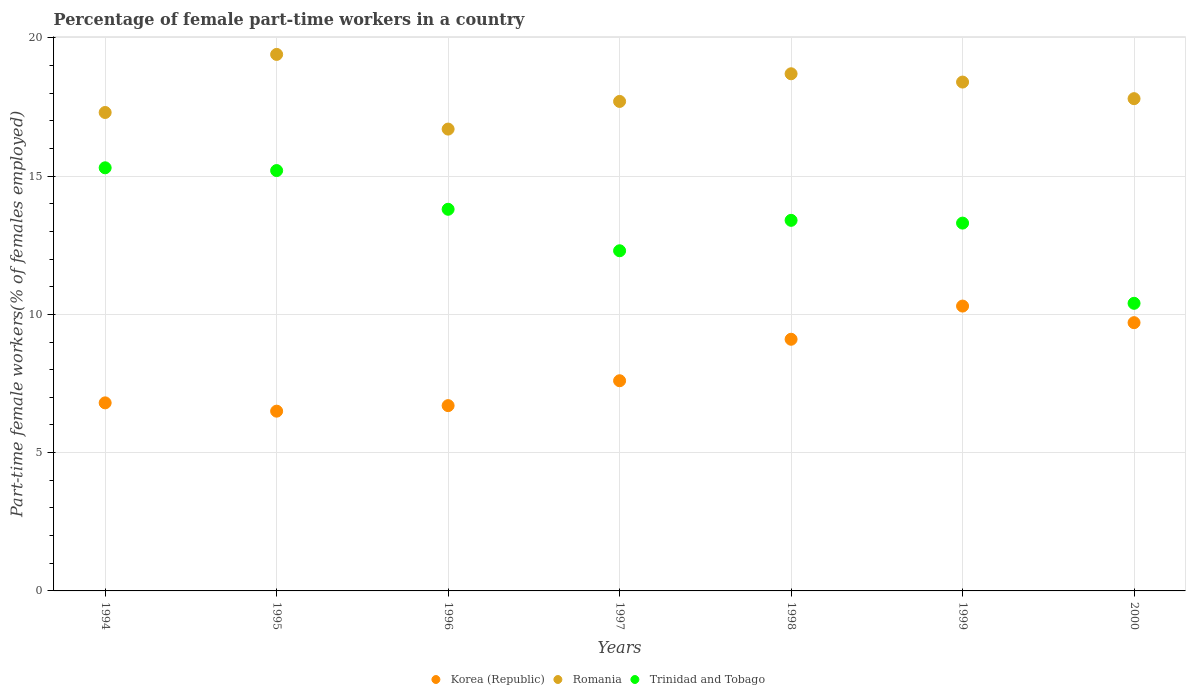How many different coloured dotlines are there?
Keep it short and to the point. 3. What is the percentage of female part-time workers in Trinidad and Tobago in 1997?
Make the answer very short. 12.3. Across all years, what is the maximum percentage of female part-time workers in Korea (Republic)?
Offer a terse response. 10.3. Across all years, what is the minimum percentage of female part-time workers in Trinidad and Tobago?
Give a very brief answer. 10.4. What is the total percentage of female part-time workers in Romania in the graph?
Make the answer very short. 126. What is the difference between the percentage of female part-time workers in Romania in 1994 and that in 1996?
Ensure brevity in your answer.  0.6. What is the difference between the percentage of female part-time workers in Korea (Republic) in 1997 and the percentage of female part-time workers in Romania in 2000?
Offer a terse response. -10.2. What is the average percentage of female part-time workers in Trinidad and Tobago per year?
Make the answer very short. 13.39. In the year 1995, what is the difference between the percentage of female part-time workers in Romania and percentage of female part-time workers in Trinidad and Tobago?
Offer a very short reply. 4.2. In how many years, is the percentage of female part-time workers in Romania greater than 16 %?
Ensure brevity in your answer.  7. What is the ratio of the percentage of female part-time workers in Trinidad and Tobago in 1994 to that in 1997?
Give a very brief answer. 1.24. What is the difference between the highest and the second highest percentage of female part-time workers in Korea (Republic)?
Your answer should be very brief. 0.6. What is the difference between the highest and the lowest percentage of female part-time workers in Korea (Republic)?
Offer a very short reply. 3.8. In how many years, is the percentage of female part-time workers in Trinidad and Tobago greater than the average percentage of female part-time workers in Trinidad and Tobago taken over all years?
Give a very brief answer. 4. Is the percentage of female part-time workers in Trinidad and Tobago strictly greater than the percentage of female part-time workers in Korea (Republic) over the years?
Give a very brief answer. Yes. How many dotlines are there?
Your response must be concise. 3. How many years are there in the graph?
Your response must be concise. 7. Does the graph contain any zero values?
Provide a short and direct response. No. Where does the legend appear in the graph?
Your response must be concise. Bottom center. What is the title of the graph?
Your answer should be compact. Percentage of female part-time workers in a country. Does "Qatar" appear as one of the legend labels in the graph?
Ensure brevity in your answer.  No. What is the label or title of the X-axis?
Give a very brief answer. Years. What is the label or title of the Y-axis?
Your answer should be very brief. Part-time female workers(% of females employed). What is the Part-time female workers(% of females employed) in Korea (Republic) in 1994?
Ensure brevity in your answer.  6.8. What is the Part-time female workers(% of females employed) in Romania in 1994?
Provide a succinct answer. 17.3. What is the Part-time female workers(% of females employed) of Trinidad and Tobago in 1994?
Offer a very short reply. 15.3. What is the Part-time female workers(% of females employed) of Romania in 1995?
Provide a succinct answer. 19.4. What is the Part-time female workers(% of females employed) of Trinidad and Tobago in 1995?
Offer a very short reply. 15.2. What is the Part-time female workers(% of females employed) of Korea (Republic) in 1996?
Offer a terse response. 6.7. What is the Part-time female workers(% of females employed) of Romania in 1996?
Offer a very short reply. 16.7. What is the Part-time female workers(% of females employed) of Trinidad and Tobago in 1996?
Give a very brief answer. 13.8. What is the Part-time female workers(% of females employed) of Korea (Republic) in 1997?
Your response must be concise. 7.6. What is the Part-time female workers(% of females employed) of Romania in 1997?
Your answer should be compact. 17.7. What is the Part-time female workers(% of females employed) in Trinidad and Tobago in 1997?
Your response must be concise. 12.3. What is the Part-time female workers(% of females employed) of Korea (Republic) in 1998?
Make the answer very short. 9.1. What is the Part-time female workers(% of females employed) of Romania in 1998?
Offer a very short reply. 18.7. What is the Part-time female workers(% of females employed) of Trinidad and Tobago in 1998?
Keep it short and to the point. 13.4. What is the Part-time female workers(% of females employed) in Korea (Republic) in 1999?
Ensure brevity in your answer.  10.3. What is the Part-time female workers(% of females employed) in Romania in 1999?
Provide a succinct answer. 18.4. What is the Part-time female workers(% of females employed) in Trinidad and Tobago in 1999?
Keep it short and to the point. 13.3. What is the Part-time female workers(% of females employed) in Korea (Republic) in 2000?
Give a very brief answer. 9.7. What is the Part-time female workers(% of females employed) of Romania in 2000?
Ensure brevity in your answer.  17.8. What is the Part-time female workers(% of females employed) in Trinidad and Tobago in 2000?
Give a very brief answer. 10.4. Across all years, what is the maximum Part-time female workers(% of females employed) in Korea (Republic)?
Offer a terse response. 10.3. Across all years, what is the maximum Part-time female workers(% of females employed) of Romania?
Give a very brief answer. 19.4. Across all years, what is the maximum Part-time female workers(% of females employed) in Trinidad and Tobago?
Your response must be concise. 15.3. Across all years, what is the minimum Part-time female workers(% of females employed) of Romania?
Provide a succinct answer. 16.7. Across all years, what is the minimum Part-time female workers(% of females employed) in Trinidad and Tobago?
Provide a succinct answer. 10.4. What is the total Part-time female workers(% of females employed) in Korea (Republic) in the graph?
Provide a succinct answer. 56.7. What is the total Part-time female workers(% of females employed) of Romania in the graph?
Keep it short and to the point. 126. What is the total Part-time female workers(% of females employed) in Trinidad and Tobago in the graph?
Provide a succinct answer. 93.7. What is the difference between the Part-time female workers(% of females employed) of Romania in 1994 and that in 1995?
Provide a short and direct response. -2.1. What is the difference between the Part-time female workers(% of females employed) in Korea (Republic) in 1994 and that in 1996?
Give a very brief answer. 0.1. What is the difference between the Part-time female workers(% of females employed) of Trinidad and Tobago in 1994 and that in 1996?
Make the answer very short. 1.5. What is the difference between the Part-time female workers(% of females employed) of Korea (Republic) in 1994 and that in 1997?
Offer a terse response. -0.8. What is the difference between the Part-time female workers(% of females employed) in Korea (Republic) in 1994 and that in 1998?
Give a very brief answer. -2.3. What is the difference between the Part-time female workers(% of females employed) in Romania in 1994 and that in 1999?
Your response must be concise. -1.1. What is the difference between the Part-time female workers(% of females employed) of Trinidad and Tobago in 1994 and that in 1999?
Offer a terse response. 2. What is the difference between the Part-time female workers(% of females employed) of Korea (Republic) in 1994 and that in 2000?
Ensure brevity in your answer.  -2.9. What is the difference between the Part-time female workers(% of females employed) in Trinidad and Tobago in 1994 and that in 2000?
Ensure brevity in your answer.  4.9. What is the difference between the Part-time female workers(% of females employed) in Korea (Republic) in 1995 and that in 1996?
Offer a very short reply. -0.2. What is the difference between the Part-time female workers(% of females employed) in Romania in 1995 and that in 1997?
Give a very brief answer. 1.7. What is the difference between the Part-time female workers(% of females employed) of Trinidad and Tobago in 1995 and that in 1997?
Give a very brief answer. 2.9. What is the difference between the Part-time female workers(% of females employed) in Korea (Republic) in 1995 and that in 1998?
Offer a terse response. -2.6. What is the difference between the Part-time female workers(% of females employed) of Trinidad and Tobago in 1995 and that in 1999?
Give a very brief answer. 1.9. What is the difference between the Part-time female workers(% of females employed) in Korea (Republic) in 1995 and that in 2000?
Make the answer very short. -3.2. What is the difference between the Part-time female workers(% of females employed) in Trinidad and Tobago in 1995 and that in 2000?
Make the answer very short. 4.8. What is the difference between the Part-time female workers(% of females employed) in Korea (Republic) in 1996 and that in 1997?
Give a very brief answer. -0.9. What is the difference between the Part-time female workers(% of females employed) of Trinidad and Tobago in 1996 and that in 1997?
Your response must be concise. 1.5. What is the difference between the Part-time female workers(% of females employed) of Korea (Republic) in 1996 and that in 1998?
Keep it short and to the point. -2.4. What is the difference between the Part-time female workers(% of females employed) of Romania in 1996 and that in 1998?
Give a very brief answer. -2. What is the difference between the Part-time female workers(% of females employed) of Trinidad and Tobago in 1996 and that in 1998?
Your answer should be very brief. 0.4. What is the difference between the Part-time female workers(% of females employed) of Trinidad and Tobago in 1996 and that in 1999?
Offer a very short reply. 0.5. What is the difference between the Part-time female workers(% of females employed) of Trinidad and Tobago in 1996 and that in 2000?
Provide a short and direct response. 3.4. What is the difference between the Part-time female workers(% of females employed) of Korea (Republic) in 1997 and that in 1998?
Provide a short and direct response. -1.5. What is the difference between the Part-time female workers(% of females employed) in Trinidad and Tobago in 1997 and that in 1998?
Give a very brief answer. -1.1. What is the difference between the Part-time female workers(% of females employed) of Korea (Republic) in 1997 and that in 1999?
Offer a terse response. -2.7. What is the difference between the Part-time female workers(% of females employed) in Trinidad and Tobago in 1997 and that in 1999?
Your answer should be compact. -1. What is the difference between the Part-time female workers(% of females employed) in Korea (Republic) in 1997 and that in 2000?
Your answer should be compact. -2.1. What is the difference between the Part-time female workers(% of females employed) in Trinidad and Tobago in 1997 and that in 2000?
Offer a very short reply. 1.9. What is the difference between the Part-time female workers(% of females employed) of Korea (Republic) in 1998 and that in 1999?
Your response must be concise. -1.2. What is the difference between the Part-time female workers(% of females employed) in Romania in 1998 and that in 1999?
Ensure brevity in your answer.  0.3. What is the difference between the Part-time female workers(% of females employed) in Romania in 1998 and that in 2000?
Keep it short and to the point. 0.9. What is the difference between the Part-time female workers(% of females employed) in Trinidad and Tobago in 1998 and that in 2000?
Provide a succinct answer. 3. What is the difference between the Part-time female workers(% of females employed) in Korea (Republic) in 1999 and that in 2000?
Give a very brief answer. 0.6. What is the difference between the Part-time female workers(% of females employed) in Romania in 1999 and that in 2000?
Your response must be concise. 0.6. What is the difference between the Part-time female workers(% of females employed) of Korea (Republic) in 1994 and the Part-time female workers(% of females employed) of Romania in 1995?
Provide a succinct answer. -12.6. What is the difference between the Part-time female workers(% of females employed) of Korea (Republic) in 1994 and the Part-time female workers(% of females employed) of Trinidad and Tobago in 1995?
Your answer should be very brief. -8.4. What is the difference between the Part-time female workers(% of females employed) in Korea (Republic) in 1994 and the Part-time female workers(% of females employed) in Romania in 1996?
Your answer should be very brief. -9.9. What is the difference between the Part-time female workers(% of females employed) of Korea (Republic) in 1994 and the Part-time female workers(% of females employed) of Trinidad and Tobago in 1996?
Your answer should be compact. -7. What is the difference between the Part-time female workers(% of females employed) in Romania in 1994 and the Part-time female workers(% of females employed) in Trinidad and Tobago in 1996?
Give a very brief answer. 3.5. What is the difference between the Part-time female workers(% of females employed) in Korea (Republic) in 1994 and the Part-time female workers(% of females employed) in Romania in 1997?
Provide a short and direct response. -10.9. What is the difference between the Part-time female workers(% of females employed) in Korea (Republic) in 1994 and the Part-time female workers(% of females employed) in Trinidad and Tobago in 1997?
Give a very brief answer. -5.5. What is the difference between the Part-time female workers(% of females employed) of Romania in 1994 and the Part-time female workers(% of females employed) of Trinidad and Tobago in 1997?
Make the answer very short. 5. What is the difference between the Part-time female workers(% of females employed) in Romania in 1994 and the Part-time female workers(% of females employed) in Trinidad and Tobago in 1998?
Ensure brevity in your answer.  3.9. What is the difference between the Part-time female workers(% of females employed) in Korea (Republic) in 1994 and the Part-time female workers(% of females employed) in Romania in 1999?
Ensure brevity in your answer.  -11.6. What is the difference between the Part-time female workers(% of females employed) of Korea (Republic) in 1994 and the Part-time female workers(% of females employed) of Trinidad and Tobago in 1999?
Ensure brevity in your answer.  -6.5. What is the difference between the Part-time female workers(% of females employed) of Romania in 1994 and the Part-time female workers(% of females employed) of Trinidad and Tobago in 1999?
Your answer should be compact. 4. What is the difference between the Part-time female workers(% of females employed) in Romania in 1995 and the Part-time female workers(% of females employed) in Trinidad and Tobago in 1996?
Provide a succinct answer. 5.6. What is the difference between the Part-time female workers(% of females employed) of Romania in 1995 and the Part-time female workers(% of females employed) of Trinidad and Tobago in 1997?
Ensure brevity in your answer.  7.1. What is the difference between the Part-time female workers(% of females employed) of Korea (Republic) in 1995 and the Part-time female workers(% of females employed) of Trinidad and Tobago in 1998?
Ensure brevity in your answer.  -6.9. What is the difference between the Part-time female workers(% of females employed) of Korea (Republic) in 1995 and the Part-time female workers(% of females employed) of Trinidad and Tobago in 1999?
Ensure brevity in your answer.  -6.8. What is the difference between the Part-time female workers(% of females employed) in Romania in 1995 and the Part-time female workers(% of females employed) in Trinidad and Tobago in 2000?
Provide a succinct answer. 9. What is the difference between the Part-time female workers(% of females employed) in Romania in 1996 and the Part-time female workers(% of females employed) in Trinidad and Tobago in 1997?
Give a very brief answer. 4.4. What is the difference between the Part-time female workers(% of females employed) in Romania in 1996 and the Part-time female workers(% of females employed) in Trinidad and Tobago in 1998?
Provide a succinct answer. 3.3. What is the difference between the Part-time female workers(% of females employed) in Korea (Republic) in 1996 and the Part-time female workers(% of females employed) in Romania in 1999?
Your response must be concise. -11.7. What is the difference between the Part-time female workers(% of females employed) of Romania in 1996 and the Part-time female workers(% of females employed) of Trinidad and Tobago in 1999?
Provide a succinct answer. 3.4. What is the difference between the Part-time female workers(% of females employed) of Korea (Republic) in 1996 and the Part-time female workers(% of females employed) of Romania in 2000?
Your response must be concise. -11.1. What is the difference between the Part-time female workers(% of females employed) of Romania in 1996 and the Part-time female workers(% of females employed) of Trinidad and Tobago in 2000?
Keep it short and to the point. 6.3. What is the difference between the Part-time female workers(% of females employed) in Korea (Republic) in 1997 and the Part-time female workers(% of females employed) in Romania in 1998?
Make the answer very short. -11.1. What is the difference between the Part-time female workers(% of females employed) in Korea (Republic) in 1997 and the Part-time female workers(% of females employed) in Trinidad and Tobago in 1998?
Offer a terse response. -5.8. What is the difference between the Part-time female workers(% of females employed) of Romania in 1997 and the Part-time female workers(% of females employed) of Trinidad and Tobago in 1999?
Keep it short and to the point. 4.4. What is the difference between the Part-time female workers(% of females employed) in Korea (Republic) in 1997 and the Part-time female workers(% of females employed) in Trinidad and Tobago in 2000?
Your answer should be very brief. -2.8. What is the difference between the Part-time female workers(% of females employed) in Korea (Republic) in 1998 and the Part-time female workers(% of females employed) in Romania in 1999?
Provide a short and direct response. -9.3. What is the difference between the Part-time female workers(% of females employed) of Korea (Republic) in 1998 and the Part-time female workers(% of females employed) of Trinidad and Tobago in 1999?
Your answer should be compact. -4.2. What is the difference between the Part-time female workers(% of females employed) in Korea (Republic) in 1998 and the Part-time female workers(% of females employed) in Trinidad and Tobago in 2000?
Your answer should be very brief. -1.3. What is the difference between the Part-time female workers(% of females employed) of Romania in 1998 and the Part-time female workers(% of females employed) of Trinidad and Tobago in 2000?
Offer a very short reply. 8.3. What is the difference between the Part-time female workers(% of females employed) of Korea (Republic) in 1999 and the Part-time female workers(% of females employed) of Romania in 2000?
Offer a very short reply. -7.5. What is the difference between the Part-time female workers(% of females employed) in Korea (Republic) in 1999 and the Part-time female workers(% of females employed) in Trinidad and Tobago in 2000?
Give a very brief answer. -0.1. What is the average Part-time female workers(% of females employed) of Romania per year?
Provide a short and direct response. 18. What is the average Part-time female workers(% of females employed) of Trinidad and Tobago per year?
Your answer should be very brief. 13.39. In the year 1994, what is the difference between the Part-time female workers(% of females employed) of Korea (Republic) and Part-time female workers(% of females employed) of Romania?
Give a very brief answer. -10.5. In the year 1994, what is the difference between the Part-time female workers(% of females employed) in Romania and Part-time female workers(% of females employed) in Trinidad and Tobago?
Make the answer very short. 2. In the year 1995, what is the difference between the Part-time female workers(% of females employed) in Korea (Republic) and Part-time female workers(% of females employed) in Romania?
Offer a very short reply. -12.9. In the year 1995, what is the difference between the Part-time female workers(% of females employed) in Romania and Part-time female workers(% of females employed) in Trinidad and Tobago?
Your answer should be compact. 4.2. In the year 1996, what is the difference between the Part-time female workers(% of females employed) of Korea (Republic) and Part-time female workers(% of females employed) of Romania?
Your answer should be compact. -10. In the year 1996, what is the difference between the Part-time female workers(% of females employed) of Korea (Republic) and Part-time female workers(% of females employed) of Trinidad and Tobago?
Provide a succinct answer. -7.1. In the year 1996, what is the difference between the Part-time female workers(% of females employed) in Romania and Part-time female workers(% of females employed) in Trinidad and Tobago?
Your answer should be compact. 2.9. In the year 1997, what is the difference between the Part-time female workers(% of females employed) in Korea (Republic) and Part-time female workers(% of females employed) in Trinidad and Tobago?
Your response must be concise. -4.7. In the year 1999, what is the difference between the Part-time female workers(% of females employed) of Korea (Republic) and Part-time female workers(% of females employed) of Trinidad and Tobago?
Make the answer very short. -3. In the year 1999, what is the difference between the Part-time female workers(% of females employed) in Romania and Part-time female workers(% of females employed) in Trinidad and Tobago?
Your answer should be very brief. 5.1. In the year 2000, what is the difference between the Part-time female workers(% of females employed) in Romania and Part-time female workers(% of females employed) in Trinidad and Tobago?
Provide a succinct answer. 7.4. What is the ratio of the Part-time female workers(% of females employed) in Korea (Republic) in 1994 to that in 1995?
Offer a very short reply. 1.05. What is the ratio of the Part-time female workers(% of females employed) of Romania in 1994 to that in 1995?
Keep it short and to the point. 0.89. What is the ratio of the Part-time female workers(% of females employed) in Trinidad and Tobago in 1994 to that in 1995?
Your answer should be very brief. 1.01. What is the ratio of the Part-time female workers(% of females employed) in Korea (Republic) in 1994 to that in 1996?
Keep it short and to the point. 1.01. What is the ratio of the Part-time female workers(% of females employed) of Romania in 1994 to that in 1996?
Make the answer very short. 1.04. What is the ratio of the Part-time female workers(% of females employed) in Trinidad and Tobago in 1994 to that in 1996?
Your answer should be compact. 1.11. What is the ratio of the Part-time female workers(% of females employed) in Korea (Republic) in 1994 to that in 1997?
Your answer should be very brief. 0.89. What is the ratio of the Part-time female workers(% of females employed) in Romania in 1994 to that in 1997?
Offer a terse response. 0.98. What is the ratio of the Part-time female workers(% of females employed) in Trinidad and Tobago in 1994 to that in 1997?
Your answer should be very brief. 1.24. What is the ratio of the Part-time female workers(% of females employed) in Korea (Republic) in 1994 to that in 1998?
Provide a short and direct response. 0.75. What is the ratio of the Part-time female workers(% of females employed) in Romania in 1994 to that in 1998?
Offer a terse response. 0.93. What is the ratio of the Part-time female workers(% of females employed) in Trinidad and Tobago in 1994 to that in 1998?
Keep it short and to the point. 1.14. What is the ratio of the Part-time female workers(% of females employed) of Korea (Republic) in 1994 to that in 1999?
Your response must be concise. 0.66. What is the ratio of the Part-time female workers(% of females employed) in Romania in 1994 to that in 1999?
Offer a terse response. 0.94. What is the ratio of the Part-time female workers(% of females employed) of Trinidad and Tobago in 1994 to that in 1999?
Your answer should be compact. 1.15. What is the ratio of the Part-time female workers(% of females employed) of Korea (Republic) in 1994 to that in 2000?
Provide a short and direct response. 0.7. What is the ratio of the Part-time female workers(% of females employed) in Romania in 1994 to that in 2000?
Offer a terse response. 0.97. What is the ratio of the Part-time female workers(% of females employed) in Trinidad and Tobago in 1994 to that in 2000?
Your response must be concise. 1.47. What is the ratio of the Part-time female workers(% of females employed) of Korea (Republic) in 1995 to that in 1996?
Make the answer very short. 0.97. What is the ratio of the Part-time female workers(% of females employed) of Romania in 1995 to that in 1996?
Provide a succinct answer. 1.16. What is the ratio of the Part-time female workers(% of females employed) in Trinidad and Tobago in 1995 to that in 1996?
Provide a short and direct response. 1.1. What is the ratio of the Part-time female workers(% of females employed) in Korea (Republic) in 1995 to that in 1997?
Keep it short and to the point. 0.86. What is the ratio of the Part-time female workers(% of females employed) in Romania in 1995 to that in 1997?
Your response must be concise. 1.1. What is the ratio of the Part-time female workers(% of females employed) of Trinidad and Tobago in 1995 to that in 1997?
Provide a short and direct response. 1.24. What is the ratio of the Part-time female workers(% of females employed) of Korea (Republic) in 1995 to that in 1998?
Offer a terse response. 0.71. What is the ratio of the Part-time female workers(% of females employed) of Romania in 1995 to that in 1998?
Offer a very short reply. 1.04. What is the ratio of the Part-time female workers(% of females employed) in Trinidad and Tobago in 1995 to that in 1998?
Provide a short and direct response. 1.13. What is the ratio of the Part-time female workers(% of females employed) in Korea (Republic) in 1995 to that in 1999?
Provide a short and direct response. 0.63. What is the ratio of the Part-time female workers(% of females employed) in Romania in 1995 to that in 1999?
Ensure brevity in your answer.  1.05. What is the ratio of the Part-time female workers(% of females employed) of Korea (Republic) in 1995 to that in 2000?
Provide a succinct answer. 0.67. What is the ratio of the Part-time female workers(% of females employed) in Romania in 1995 to that in 2000?
Provide a short and direct response. 1.09. What is the ratio of the Part-time female workers(% of females employed) in Trinidad and Tobago in 1995 to that in 2000?
Offer a terse response. 1.46. What is the ratio of the Part-time female workers(% of females employed) of Korea (Republic) in 1996 to that in 1997?
Keep it short and to the point. 0.88. What is the ratio of the Part-time female workers(% of females employed) of Romania in 1996 to that in 1997?
Provide a short and direct response. 0.94. What is the ratio of the Part-time female workers(% of females employed) in Trinidad and Tobago in 1996 to that in 1997?
Your response must be concise. 1.12. What is the ratio of the Part-time female workers(% of females employed) of Korea (Republic) in 1996 to that in 1998?
Provide a short and direct response. 0.74. What is the ratio of the Part-time female workers(% of females employed) of Romania in 1996 to that in 1998?
Keep it short and to the point. 0.89. What is the ratio of the Part-time female workers(% of females employed) in Trinidad and Tobago in 1996 to that in 1998?
Make the answer very short. 1.03. What is the ratio of the Part-time female workers(% of females employed) of Korea (Republic) in 1996 to that in 1999?
Provide a short and direct response. 0.65. What is the ratio of the Part-time female workers(% of females employed) in Romania in 1996 to that in 1999?
Your answer should be very brief. 0.91. What is the ratio of the Part-time female workers(% of females employed) of Trinidad and Tobago in 1996 to that in 1999?
Your response must be concise. 1.04. What is the ratio of the Part-time female workers(% of females employed) of Korea (Republic) in 1996 to that in 2000?
Provide a short and direct response. 0.69. What is the ratio of the Part-time female workers(% of females employed) in Romania in 1996 to that in 2000?
Your answer should be compact. 0.94. What is the ratio of the Part-time female workers(% of females employed) in Trinidad and Tobago in 1996 to that in 2000?
Provide a short and direct response. 1.33. What is the ratio of the Part-time female workers(% of females employed) in Korea (Republic) in 1997 to that in 1998?
Offer a terse response. 0.84. What is the ratio of the Part-time female workers(% of females employed) in Romania in 1997 to that in 1998?
Provide a short and direct response. 0.95. What is the ratio of the Part-time female workers(% of females employed) in Trinidad and Tobago in 1997 to that in 1998?
Make the answer very short. 0.92. What is the ratio of the Part-time female workers(% of females employed) in Korea (Republic) in 1997 to that in 1999?
Provide a succinct answer. 0.74. What is the ratio of the Part-time female workers(% of females employed) in Trinidad and Tobago in 1997 to that in 1999?
Make the answer very short. 0.92. What is the ratio of the Part-time female workers(% of females employed) of Korea (Republic) in 1997 to that in 2000?
Your response must be concise. 0.78. What is the ratio of the Part-time female workers(% of females employed) in Trinidad and Tobago in 1997 to that in 2000?
Offer a terse response. 1.18. What is the ratio of the Part-time female workers(% of females employed) of Korea (Republic) in 1998 to that in 1999?
Give a very brief answer. 0.88. What is the ratio of the Part-time female workers(% of females employed) in Romania in 1998 to that in 1999?
Provide a short and direct response. 1.02. What is the ratio of the Part-time female workers(% of females employed) of Trinidad and Tobago in 1998 to that in 1999?
Provide a short and direct response. 1.01. What is the ratio of the Part-time female workers(% of females employed) of Korea (Republic) in 1998 to that in 2000?
Provide a succinct answer. 0.94. What is the ratio of the Part-time female workers(% of females employed) in Romania in 1998 to that in 2000?
Make the answer very short. 1.05. What is the ratio of the Part-time female workers(% of females employed) of Trinidad and Tobago in 1998 to that in 2000?
Give a very brief answer. 1.29. What is the ratio of the Part-time female workers(% of females employed) of Korea (Republic) in 1999 to that in 2000?
Your answer should be compact. 1.06. What is the ratio of the Part-time female workers(% of females employed) in Romania in 1999 to that in 2000?
Offer a very short reply. 1.03. What is the ratio of the Part-time female workers(% of females employed) of Trinidad and Tobago in 1999 to that in 2000?
Offer a terse response. 1.28. What is the difference between the highest and the lowest Part-time female workers(% of females employed) in Trinidad and Tobago?
Provide a short and direct response. 4.9. 